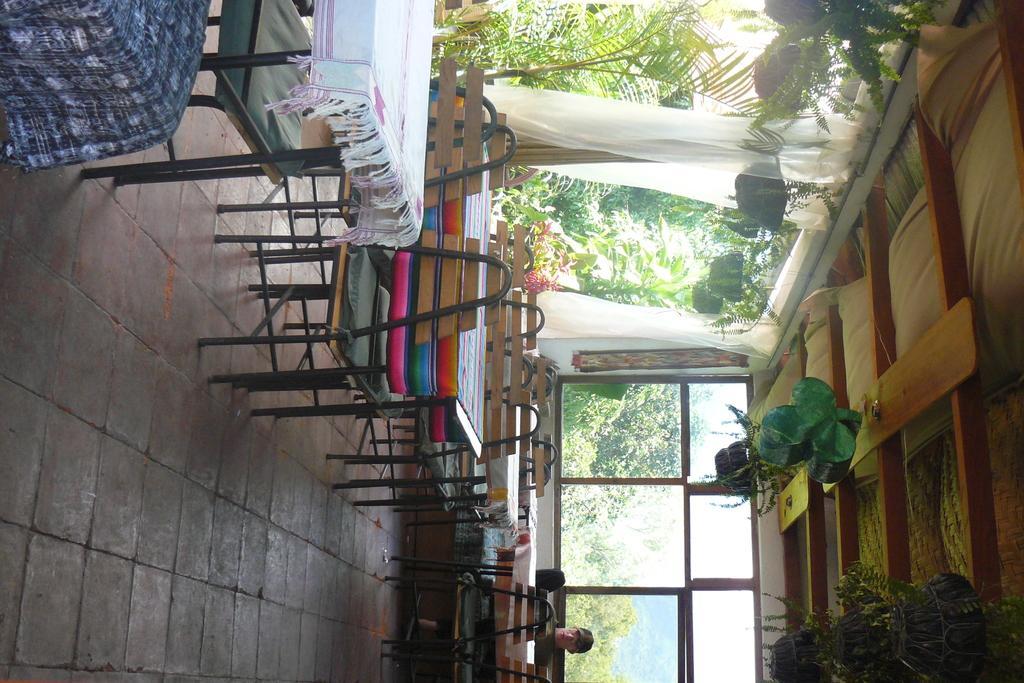Can you describe this image briefly? In this image there are tables and chairs. At the bottom of the image there is a floor. On the right side of the image there is a person sitting on the chair. In the background of the image there are windows through which we can see trees. On the left side of the image there are curtains. In the background of the image there are plants. 